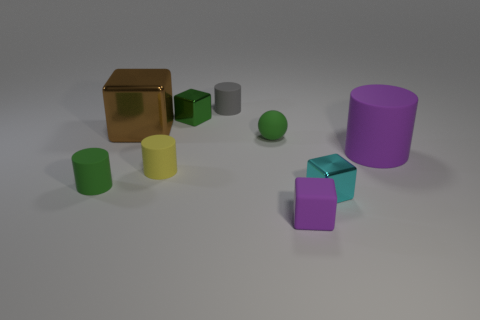Subtract 1 cylinders. How many cylinders are left? 3 Add 1 tiny yellow balls. How many objects exist? 10 Subtract all cubes. How many objects are left? 5 Add 6 gray matte things. How many gray matte things are left? 7 Add 1 cyan metal balls. How many cyan metal balls exist? 1 Subtract 1 gray cylinders. How many objects are left? 8 Subtract all large green rubber spheres. Subtract all gray rubber objects. How many objects are left? 8 